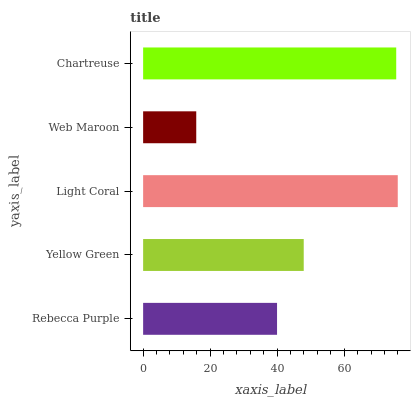Is Web Maroon the minimum?
Answer yes or no. Yes. Is Light Coral the maximum?
Answer yes or no. Yes. Is Yellow Green the minimum?
Answer yes or no. No. Is Yellow Green the maximum?
Answer yes or no. No. Is Yellow Green greater than Rebecca Purple?
Answer yes or no. Yes. Is Rebecca Purple less than Yellow Green?
Answer yes or no. Yes. Is Rebecca Purple greater than Yellow Green?
Answer yes or no. No. Is Yellow Green less than Rebecca Purple?
Answer yes or no. No. Is Yellow Green the high median?
Answer yes or no. Yes. Is Yellow Green the low median?
Answer yes or no. Yes. Is Light Coral the high median?
Answer yes or no. No. Is Light Coral the low median?
Answer yes or no. No. 